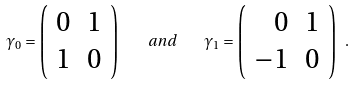<formula> <loc_0><loc_0><loc_500><loc_500>\gamma _ { 0 } = \left ( \begin{array} { r r } 0 & 1 \\ 1 & 0 \end{array} \right ) \quad a n d \quad \gamma _ { 1 } = \left ( \begin{array} { r r } 0 & 1 \\ - 1 & 0 \end{array} \right ) \ .</formula> 